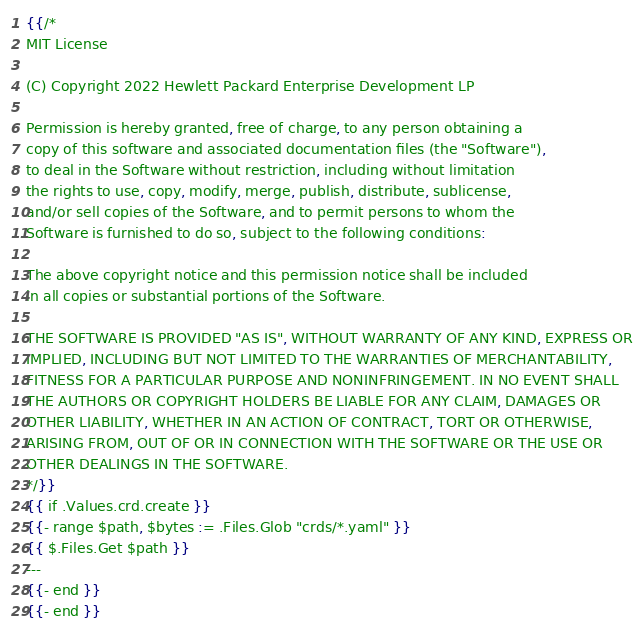Convert code to text. <code><loc_0><loc_0><loc_500><loc_500><_YAML_>{{/*
MIT License

(C) Copyright 2022 Hewlett Packard Enterprise Development LP

Permission is hereby granted, free of charge, to any person obtaining a
copy of this software and associated documentation files (the "Software"),
to deal in the Software without restriction, including without limitation
the rights to use, copy, modify, merge, publish, distribute, sublicense,
and/or sell copies of the Software, and to permit persons to whom the
Software is furnished to do so, subject to the following conditions:

The above copyright notice and this permission notice shall be included
in all copies or substantial portions of the Software.

THE SOFTWARE IS PROVIDED "AS IS", WITHOUT WARRANTY OF ANY KIND, EXPRESS OR
IMPLIED, INCLUDING BUT NOT LIMITED TO THE WARRANTIES OF MERCHANTABILITY,
FITNESS FOR A PARTICULAR PURPOSE AND NONINFRINGEMENT. IN NO EVENT SHALL
THE AUTHORS OR COPYRIGHT HOLDERS BE LIABLE FOR ANY CLAIM, DAMAGES OR
OTHER LIABILITY, WHETHER IN AN ACTION OF CONTRACT, TORT OR OTHERWISE,
ARISING FROM, OUT OF OR IN CONNECTION WITH THE SOFTWARE OR THE USE OR
OTHER DEALINGS IN THE SOFTWARE.
*/}}
{{ if .Values.crd.create }}
{{- range $path, $bytes := .Files.Glob "crds/*.yaml" }}
{{ $.Files.Get $path }}
---
{{- end }}
{{- end }}
</code> 